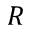Convert formula to latex. <formula><loc_0><loc_0><loc_500><loc_500>R</formula> 